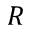Convert formula to latex. <formula><loc_0><loc_0><loc_500><loc_500>R</formula> 